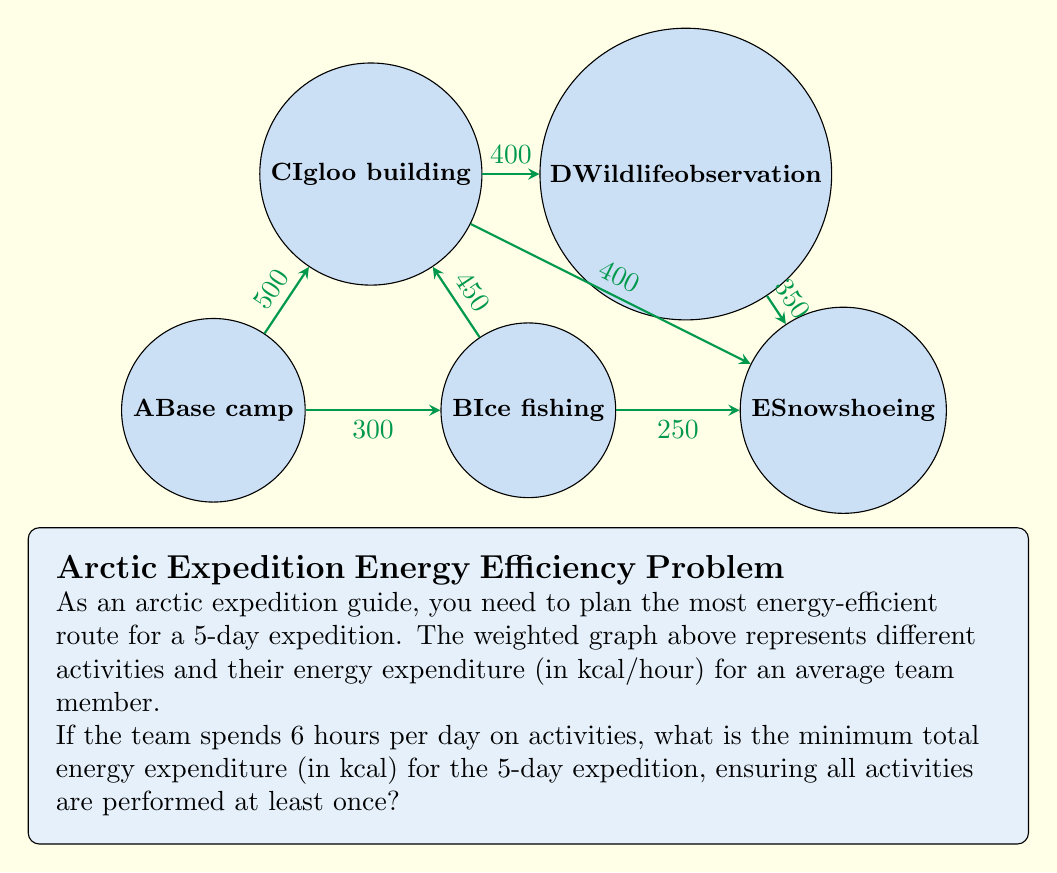Help me with this question. To solve this problem, we'll use Dijkstra's algorithm to find the shortest path that includes all activities, and then calculate the total energy expenditure.

Step 1: Identify the minimum spanning tree (MST) to ensure all activities are connected.
The MST is: A-B (300), B-E (250), B-C (450), C-D (400)
Total weight of MST: 1400 kcal/hour

Step 2: Find the shortest path that includes all vertices using the MST as a guide.
Optimal path: A → B → E → B → C → D → C → B → A
Path weights: 300 + 250 + 250 + 450 + 400 + 400 + 450 + 300 = 2800 kcal/hour

Step 3: Calculate total energy expenditure for the expedition.
Daily activity time: 6 hours
Number of days: 5
Total energy expenditure = 2800 kcal/hour × 6 hours/day × 5 days = 84000 kcal

Therefore, the minimum total energy expenditure for the 5-day expedition, ensuring all activities are performed at least once, is 84000 kcal.
Answer: 84000 kcal 